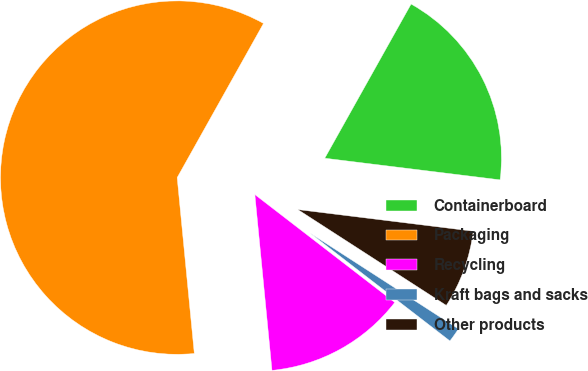<chart> <loc_0><loc_0><loc_500><loc_500><pie_chart><fcel>Containerboard<fcel>Packaging<fcel>Recycling<fcel>Kraft bags and sacks<fcel>Other products<nl><fcel>18.83%<fcel>59.67%<fcel>13.0%<fcel>1.33%<fcel>7.17%<nl></chart> 